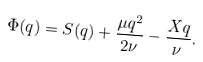<formula> <loc_0><loc_0><loc_500><loc_500>\Phi ( q ) = S ( q ) + \frac { \mu q ^ { 2 } } { 2 \nu } - \frac { X q } { \nu } .</formula> 